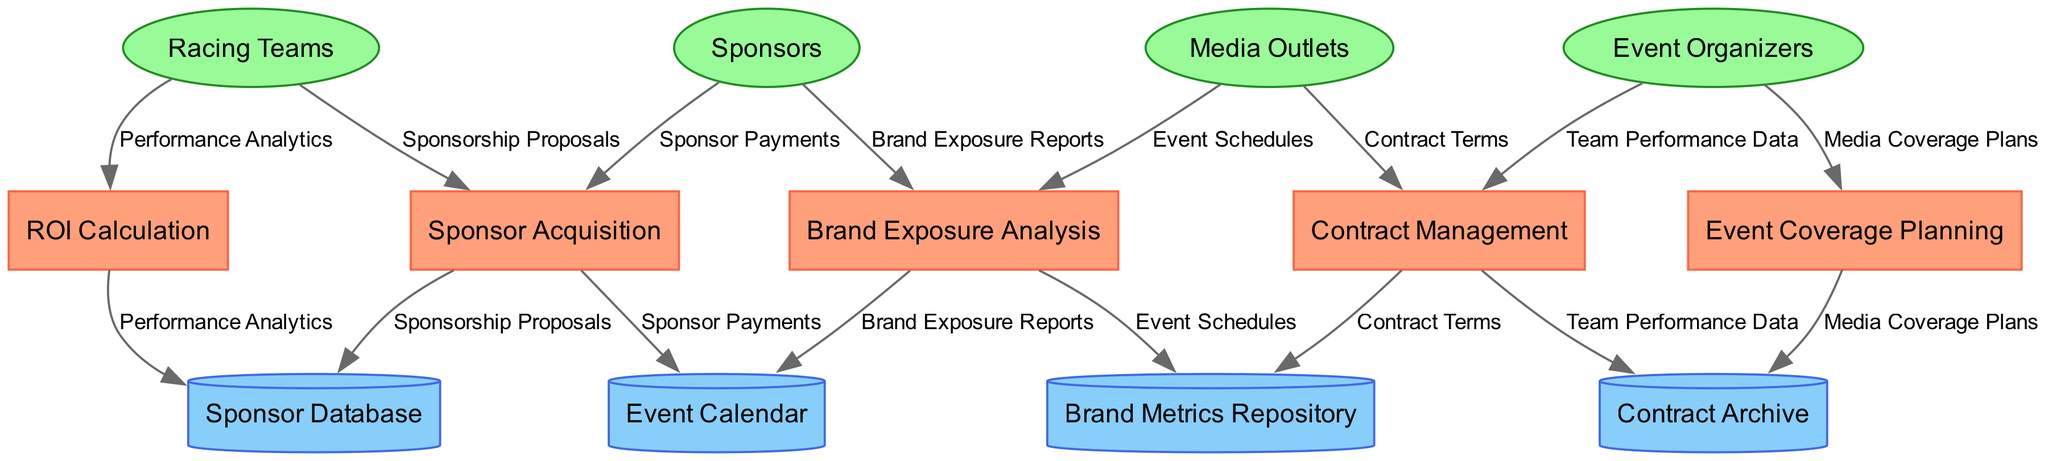What is the total number of processes in the diagram? The diagram lists five distinct processes that are part of the sponsorship management system. Counting these, we find they are: Sponsor Acquisition, Brand Exposure Analysis, Contract Management, Event Coverage Planning, and ROI Calculation.
Answer: 5 What is the shape used for external entities? In the diagram, external entities are represented using ellipses, which is a standard convention for visualizing actors or participants outside of the main processes.
Answer: ellipse Which external entity is directly connected to the 'Sponsor Acquisition' process? By examining the flow connections in the diagram, it's noted that the external entities feed into various processes. The 'Sponsor Acquisition' process is connected to the external entity labeled 'Sponsors'.
Answer: Sponsors How many data flows are depicted in the diagram? The diagram illustrates eight distinct data flows that connect the external entities, processes, and data stores. This involves understanding all flows from the entities to the processes and subsequently to the data stores.
Answer: 8 Which data store is linked to the 'ROI Calculation' process? In tracing the connections from the 'ROI Calculation' process, we look for its associated data store. The corresponding data store connected to this process is the 'Brand Metrics Repository', which contains metrics relevant for calculating return on investment.
Answer: Brand Metrics Repository How many external entities are present in the diagram? The diagram features four external entities involved in the sponsorship management system, specifically: Racing Teams, Sponsors, Media Outlets, and Event Organizers. By counting these, we find there are exactly four.
Answer: 4 What type of relationship is represented between processes and data stores? The relationship depicted between processes and data stores in the diagram signifies a data flow direction, indicating that processes utilize or modify the data stored in these repositories, thus reflecting a dependent relationship.
Answer: data flow Which process receives 'Performance Analytics' as a data flow? By analyzing the data flow connections, it's established that 'Performance Analytics' is fed into the 'Brand Exposure Analysis' process, highlighting its role in understanding brand performance during events.
Answer: Brand Exposure Analysis 